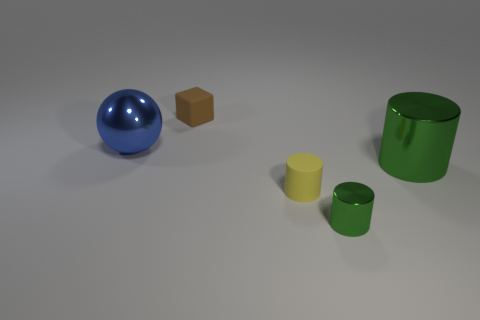There is a green metallic object that is to the left of the big thing on the right side of the metallic object on the left side of the small cube; what is its shape?
Your answer should be compact. Cylinder. What size is the cylinder that is made of the same material as the big green object?
Ensure brevity in your answer.  Small. Is the number of tiny brown matte things greater than the number of green matte cylinders?
Provide a short and direct response. Yes. What is the material of the green object that is the same size as the blue thing?
Offer a very short reply. Metal. There is a green metallic thing that is in front of the yellow cylinder; is its size the same as the brown block?
Provide a succinct answer. Yes. What number of spheres are either small yellow objects or rubber things?
Your answer should be compact. 0. What is the large thing right of the block made of?
Provide a short and direct response. Metal. Are there fewer small yellow things than big objects?
Offer a very short reply. Yes. What is the size of the metal thing that is both behind the tiny shiny object and right of the tiny block?
Your response must be concise. Large. There is a rubber thing that is behind the thing to the left of the matte object behind the big sphere; how big is it?
Provide a short and direct response. Small. 